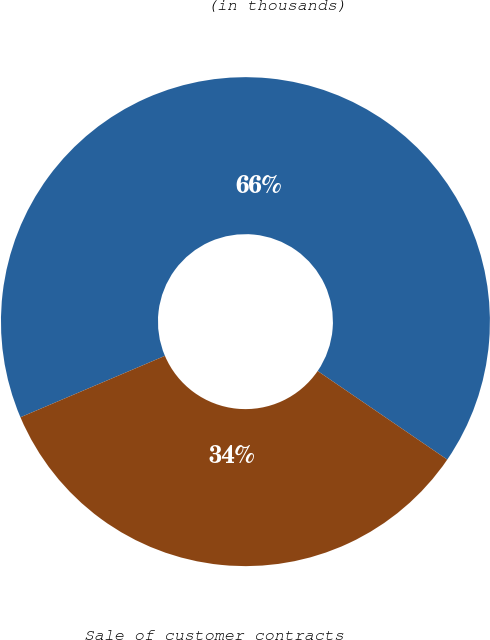Convert chart. <chart><loc_0><loc_0><loc_500><loc_500><pie_chart><fcel>(in thousands)<fcel>Sale of customer contracts<nl><fcel>65.94%<fcel>34.06%<nl></chart> 